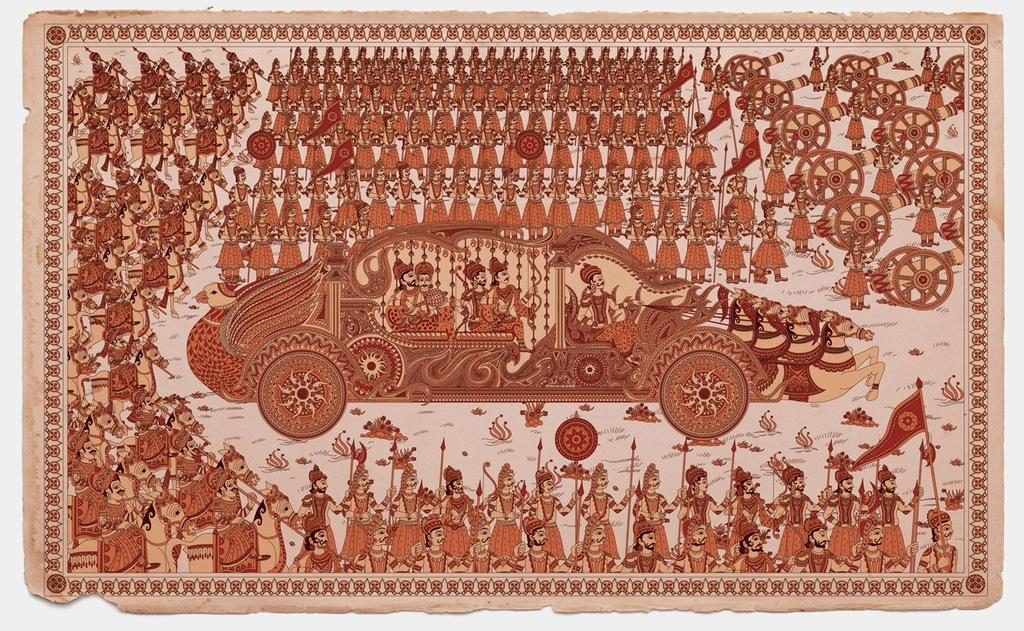What is featured in the image that contains people and objects? There is a poster in the image that contains people holding arrows, animals, flags, a vehicle, and other objects. Can you describe the people holding arrows on the poster? The people on the poster are holding arrows. What type of animals are depicted on the poster? Animals are depicted on the poster, but the specific type cannot be determined from the provided facts. What other objects are present on the poster besides the people, animals, flags, and vehicle? There are other objects on the poster, but their nature cannot be determined from the provided facts. How many flowers are being sorted by the chalk in the image? There is no chalk or flowers present in the image. 